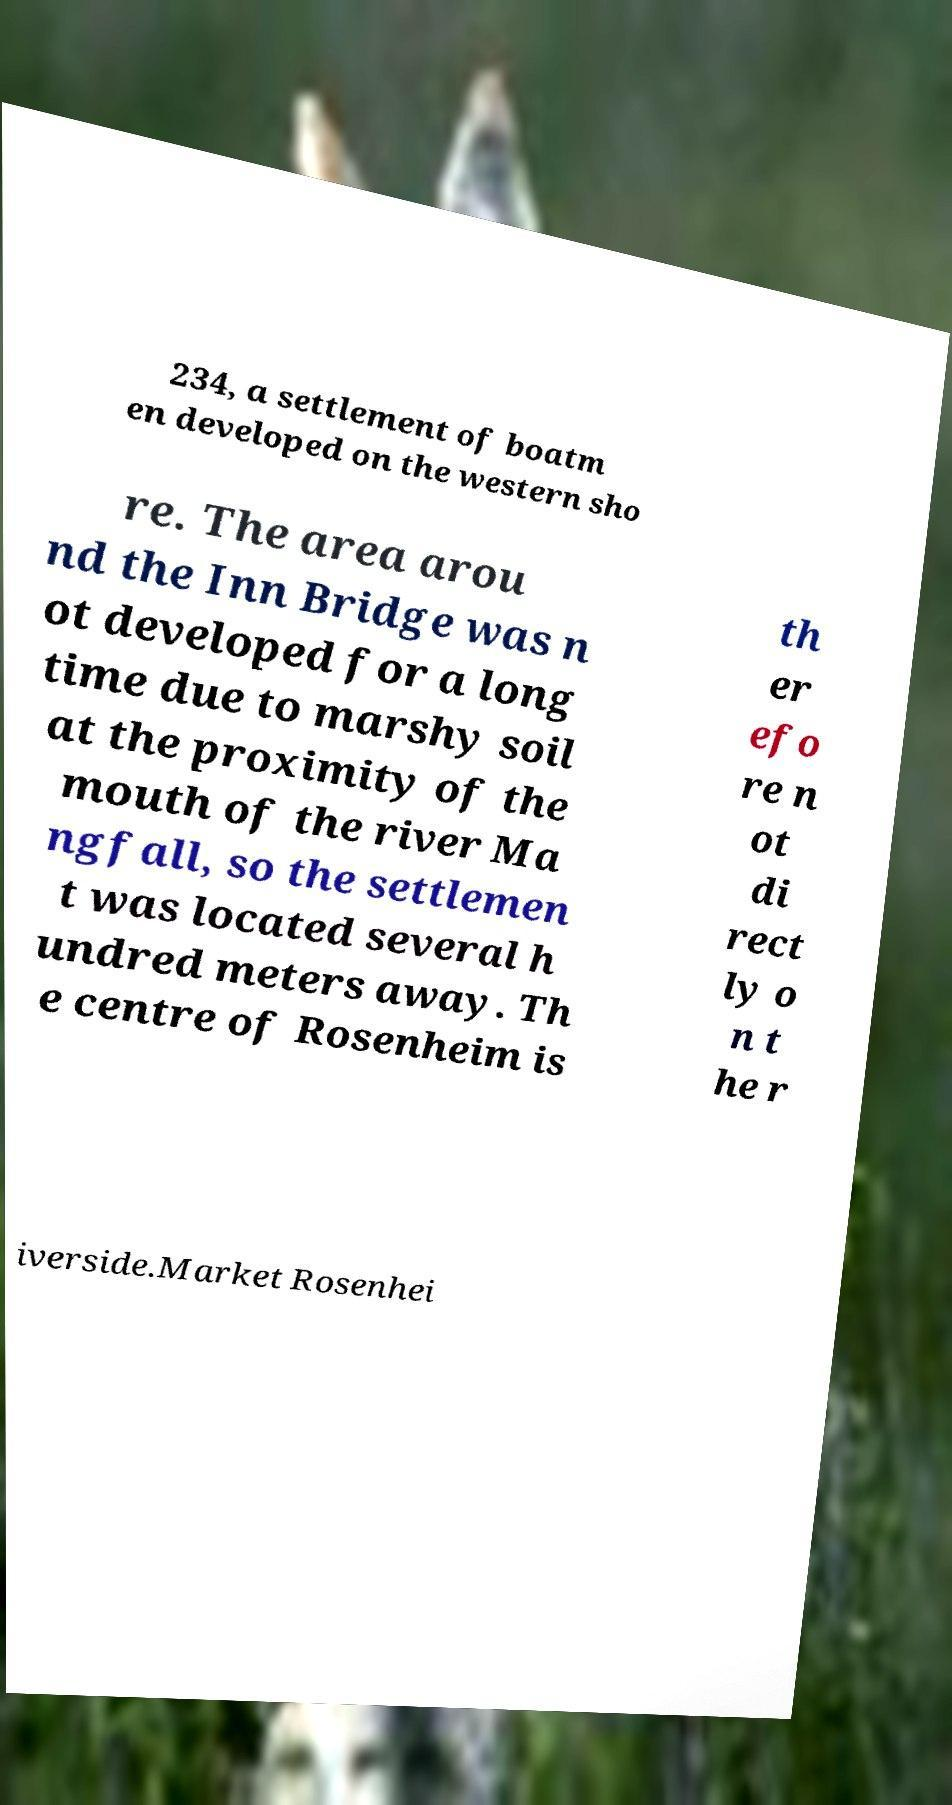Can you accurately transcribe the text from the provided image for me? 234, a settlement of boatm en developed on the western sho re. The area arou nd the Inn Bridge was n ot developed for a long time due to marshy soil at the proximity of the mouth of the river Ma ngfall, so the settlemen t was located several h undred meters away. Th e centre of Rosenheim is th er efo re n ot di rect ly o n t he r iverside.Market Rosenhei 